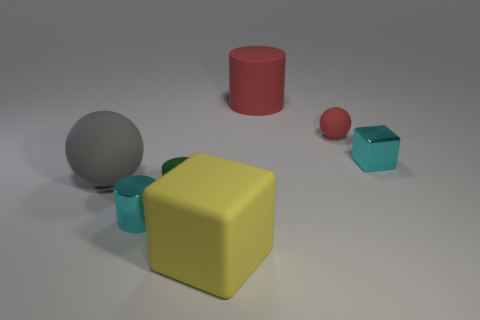Is there anything else of the same color as the rubber cylinder?
Your response must be concise. Yes. There is a cube behind the small cyan cylinder; is it the same color as the metal cylinder that is in front of the green metal cylinder?
Your answer should be compact. Yes. What size is the rubber cylinder that is the same color as the tiny rubber thing?
Provide a succinct answer. Large. There is a tiny ball that is the same color as the large cylinder; what is its material?
Make the answer very short. Rubber. What is the color of the tiny rubber thing?
Provide a short and direct response. Red. What number of big gray matte objects are the same shape as the small green metal thing?
Your answer should be very brief. 0. Is the cylinder in front of the tiny green metallic object made of the same material as the cylinder that is behind the cyan block?
Your answer should be compact. No. There is a object that is to the right of the rubber ball right of the big red object; what size is it?
Ensure brevity in your answer.  Small. What material is the tiny green thing that is the same shape as the big red rubber thing?
Make the answer very short. Metal. Is the shape of the cyan object that is behind the tiny green metal cylinder the same as the large thing that is in front of the cyan metallic cylinder?
Make the answer very short. Yes. 